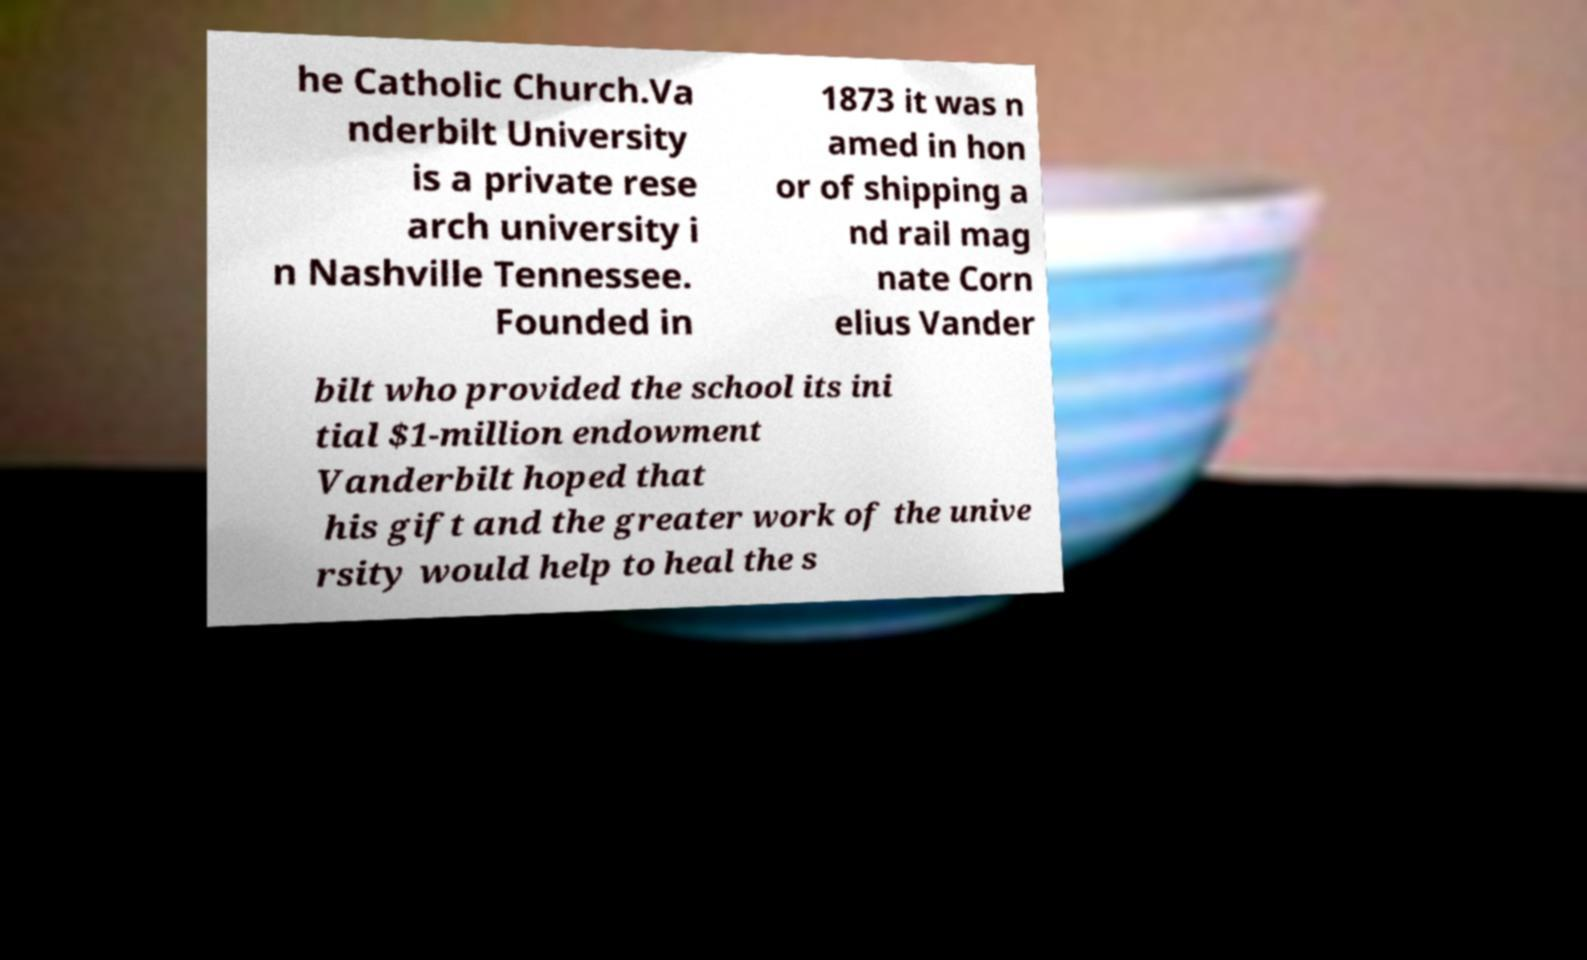Can you read and provide the text displayed in the image?This photo seems to have some interesting text. Can you extract and type it out for me? he Catholic Church.Va nderbilt University is a private rese arch university i n Nashville Tennessee. Founded in 1873 it was n amed in hon or of shipping a nd rail mag nate Corn elius Vander bilt who provided the school its ini tial $1-million endowment Vanderbilt hoped that his gift and the greater work of the unive rsity would help to heal the s 